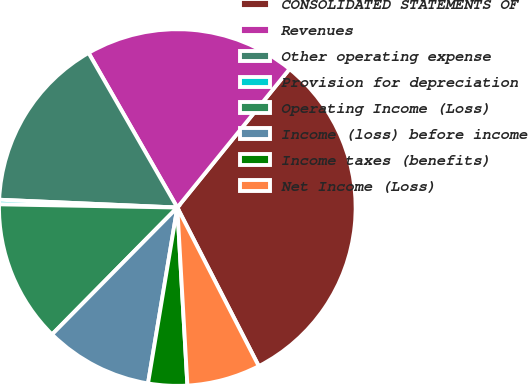<chart> <loc_0><loc_0><loc_500><loc_500><pie_chart><fcel>CONSOLIDATED STATEMENTS OF<fcel>Revenues<fcel>Other operating expense<fcel>Provision for depreciation<fcel>Operating Income (Loss)<fcel>Income (loss) before income<fcel>Income taxes (benefits)<fcel>Net Income (Loss)<nl><fcel>31.61%<fcel>19.13%<fcel>16.01%<fcel>0.41%<fcel>12.89%<fcel>9.77%<fcel>3.53%<fcel>6.65%<nl></chart> 